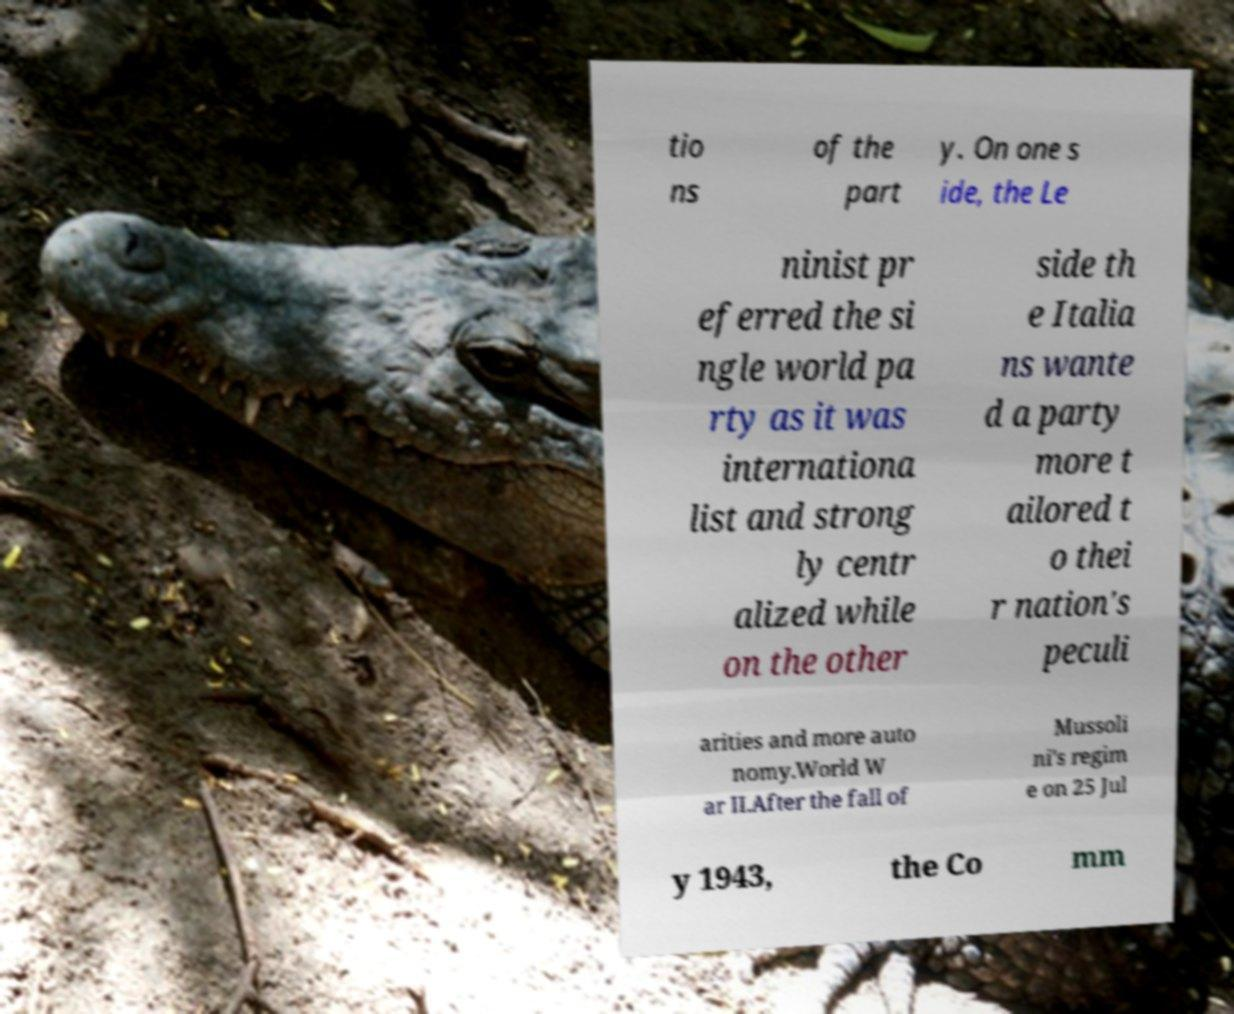Please read and relay the text visible in this image. What does it say? tio ns of the part y. On one s ide, the Le ninist pr eferred the si ngle world pa rty as it was internationa list and strong ly centr alized while on the other side th e Italia ns wante d a party more t ailored t o thei r nation's peculi arities and more auto nomy.World W ar II.After the fall of Mussoli ni's regim e on 25 Jul y 1943, the Co mm 